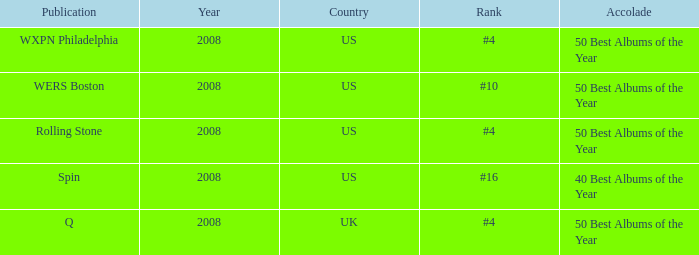Which publication happened in the UK? Q. 